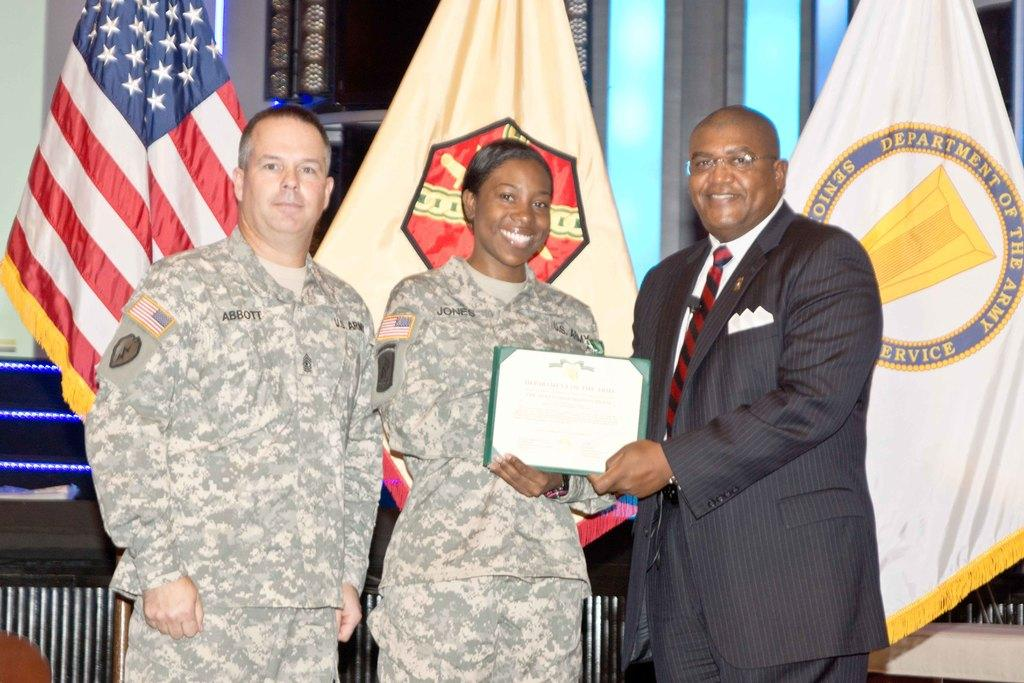How many people are in the foreground of the image? There are two men and a woman in the foreground of the image. What are the individuals in the foreground doing? The individuals are standing and posing for a camera. What can be seen in the background of the image? There are flags, lights, and a wall in the background of the image. What type of advertisement is displayed on the wall in the image? There is no advertisement visible on the wall in the image. What is the size of the flags in the background of the image? The size of the flags cannot be determined from the image alone. 